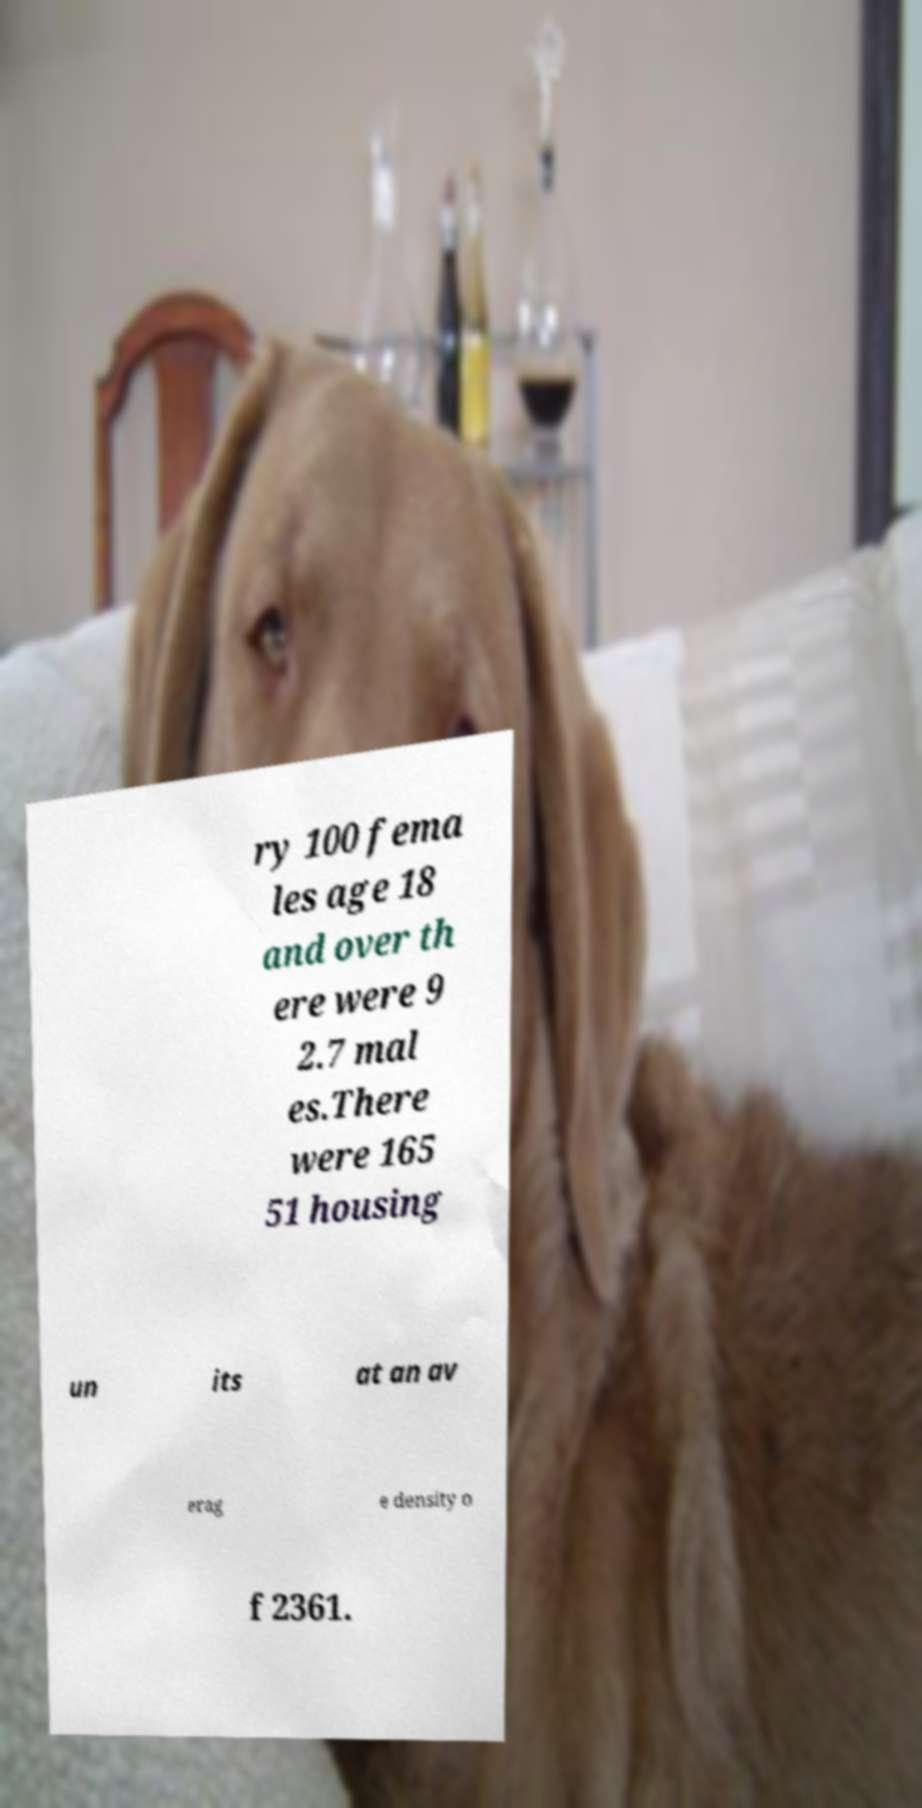Can you accurately transcribe the text from the provided image for me? ry 100 fema les age 18 and over th ere were 9 2.7 mal es.There were 165 51 housing un its at an av erag e density o f 2361. 